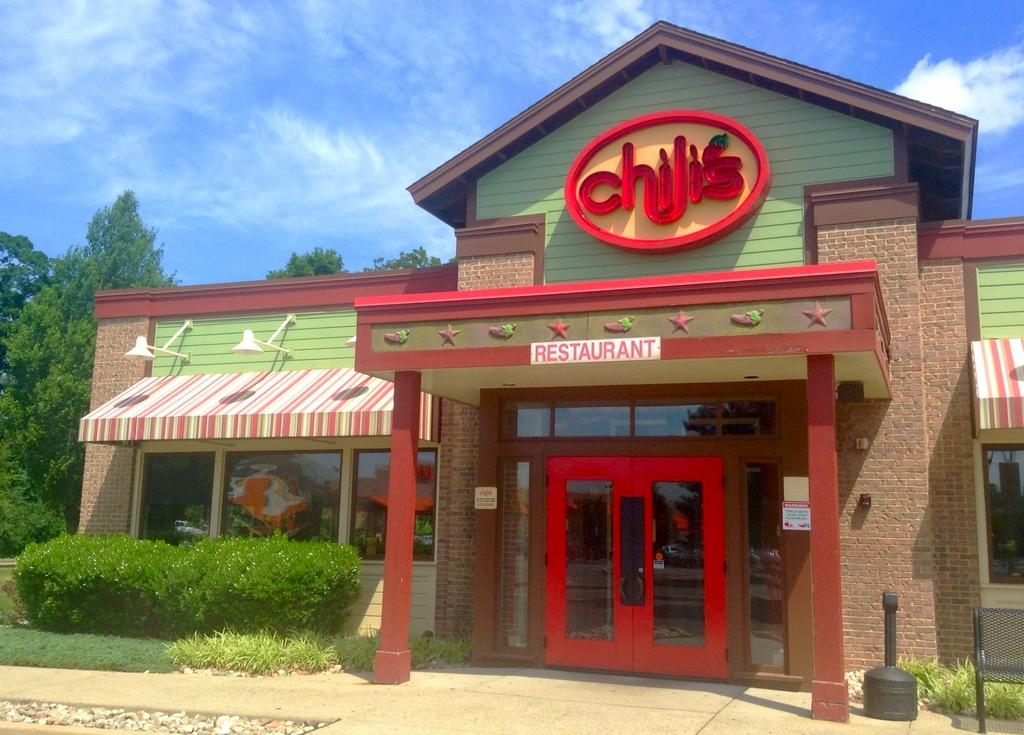What is located in the foreground of the image? There is a building, pavement, and plants in the foreground of the image. What can be seen in the background of the image? There are trees and the sky visible in the background of the image. Are there any clouds visible in the sky? Yes, there is a cloud visible in the background of the image. What type of news can be heard coming from the building in the image? There is no indication in the image that news is being broadcast or discussed in the building. What is the acoustics of the plants in the foreground of the image? Plants do not have acoustics, as they are not capable of producing or transmitting sound. 